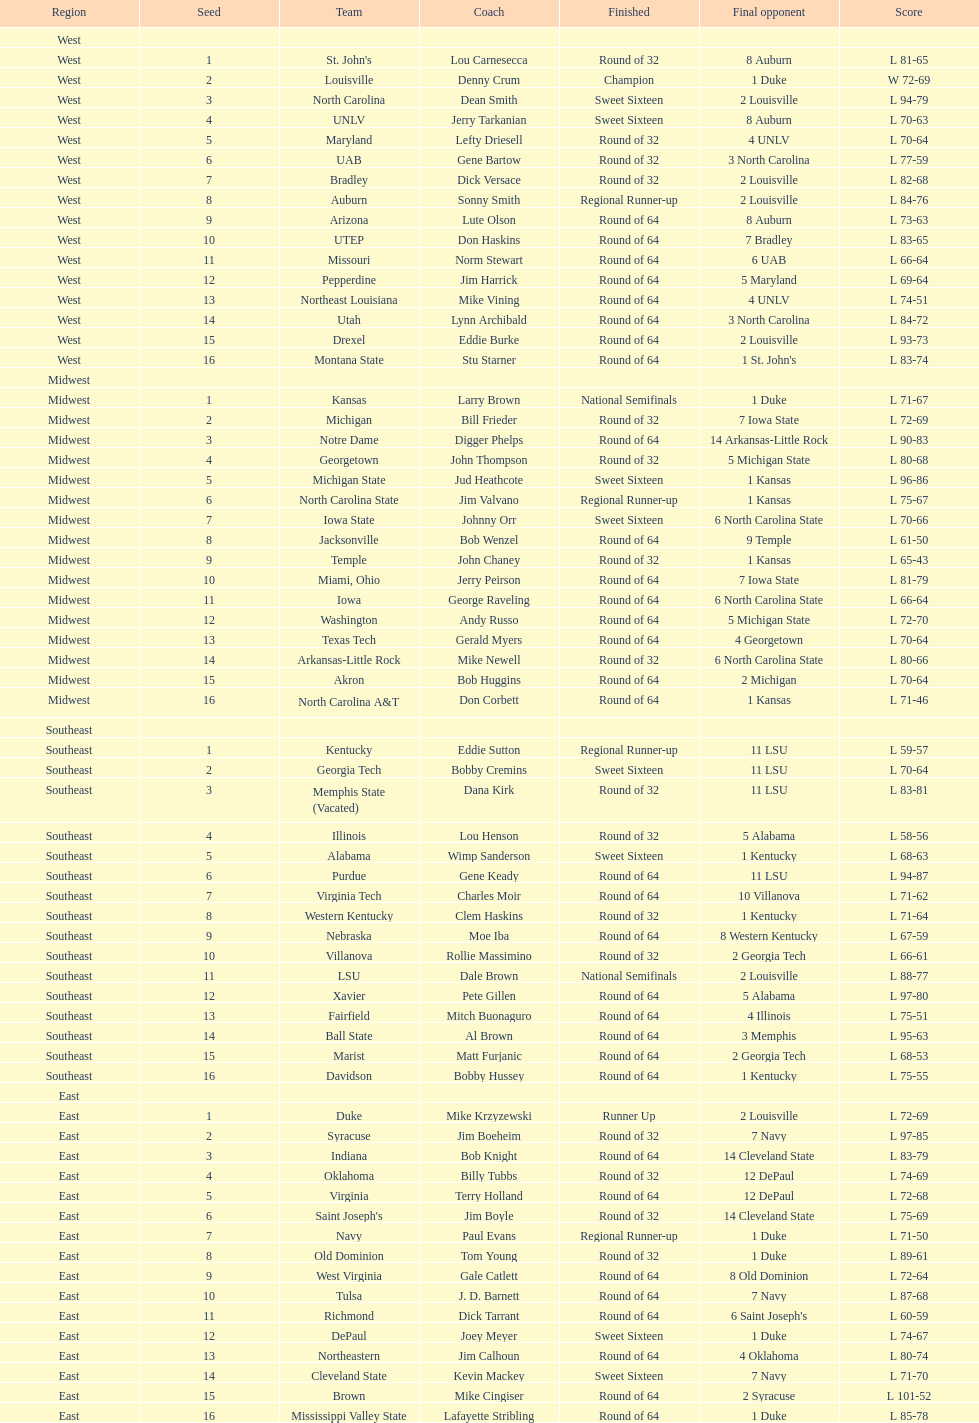Who was the only champion? Louisville. 